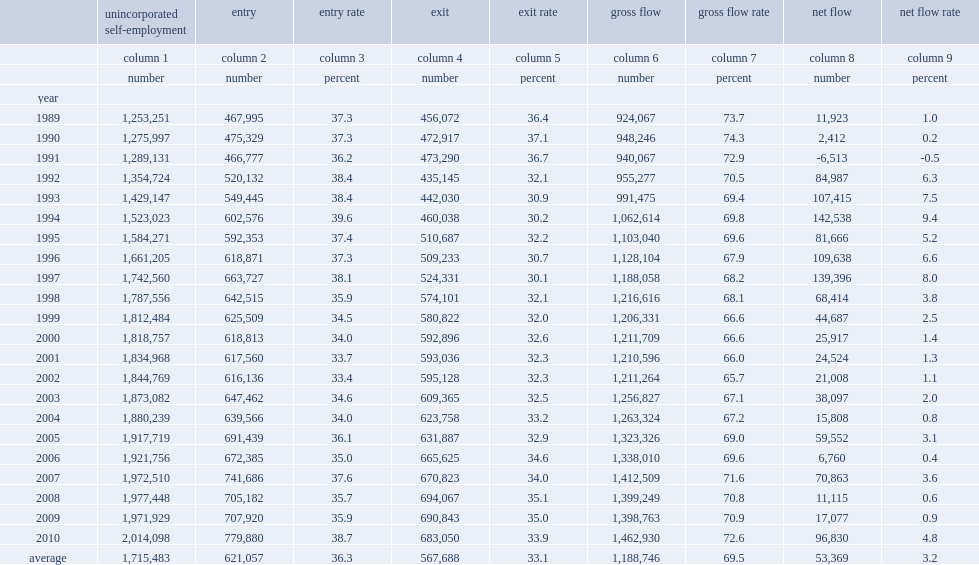How many the gross flows into and out of unincorporated self-employment averaged per year between 1989 and 2010? 1188746.0. What's the percent of the gross flows into and out of unincorporated self-employment amounted to of the total unincorporated self-employed population between 1989 and 2010? 69.5. How many individuals the unincorporated self-employment sector gaining per year in average during the same period? 53369.0. 